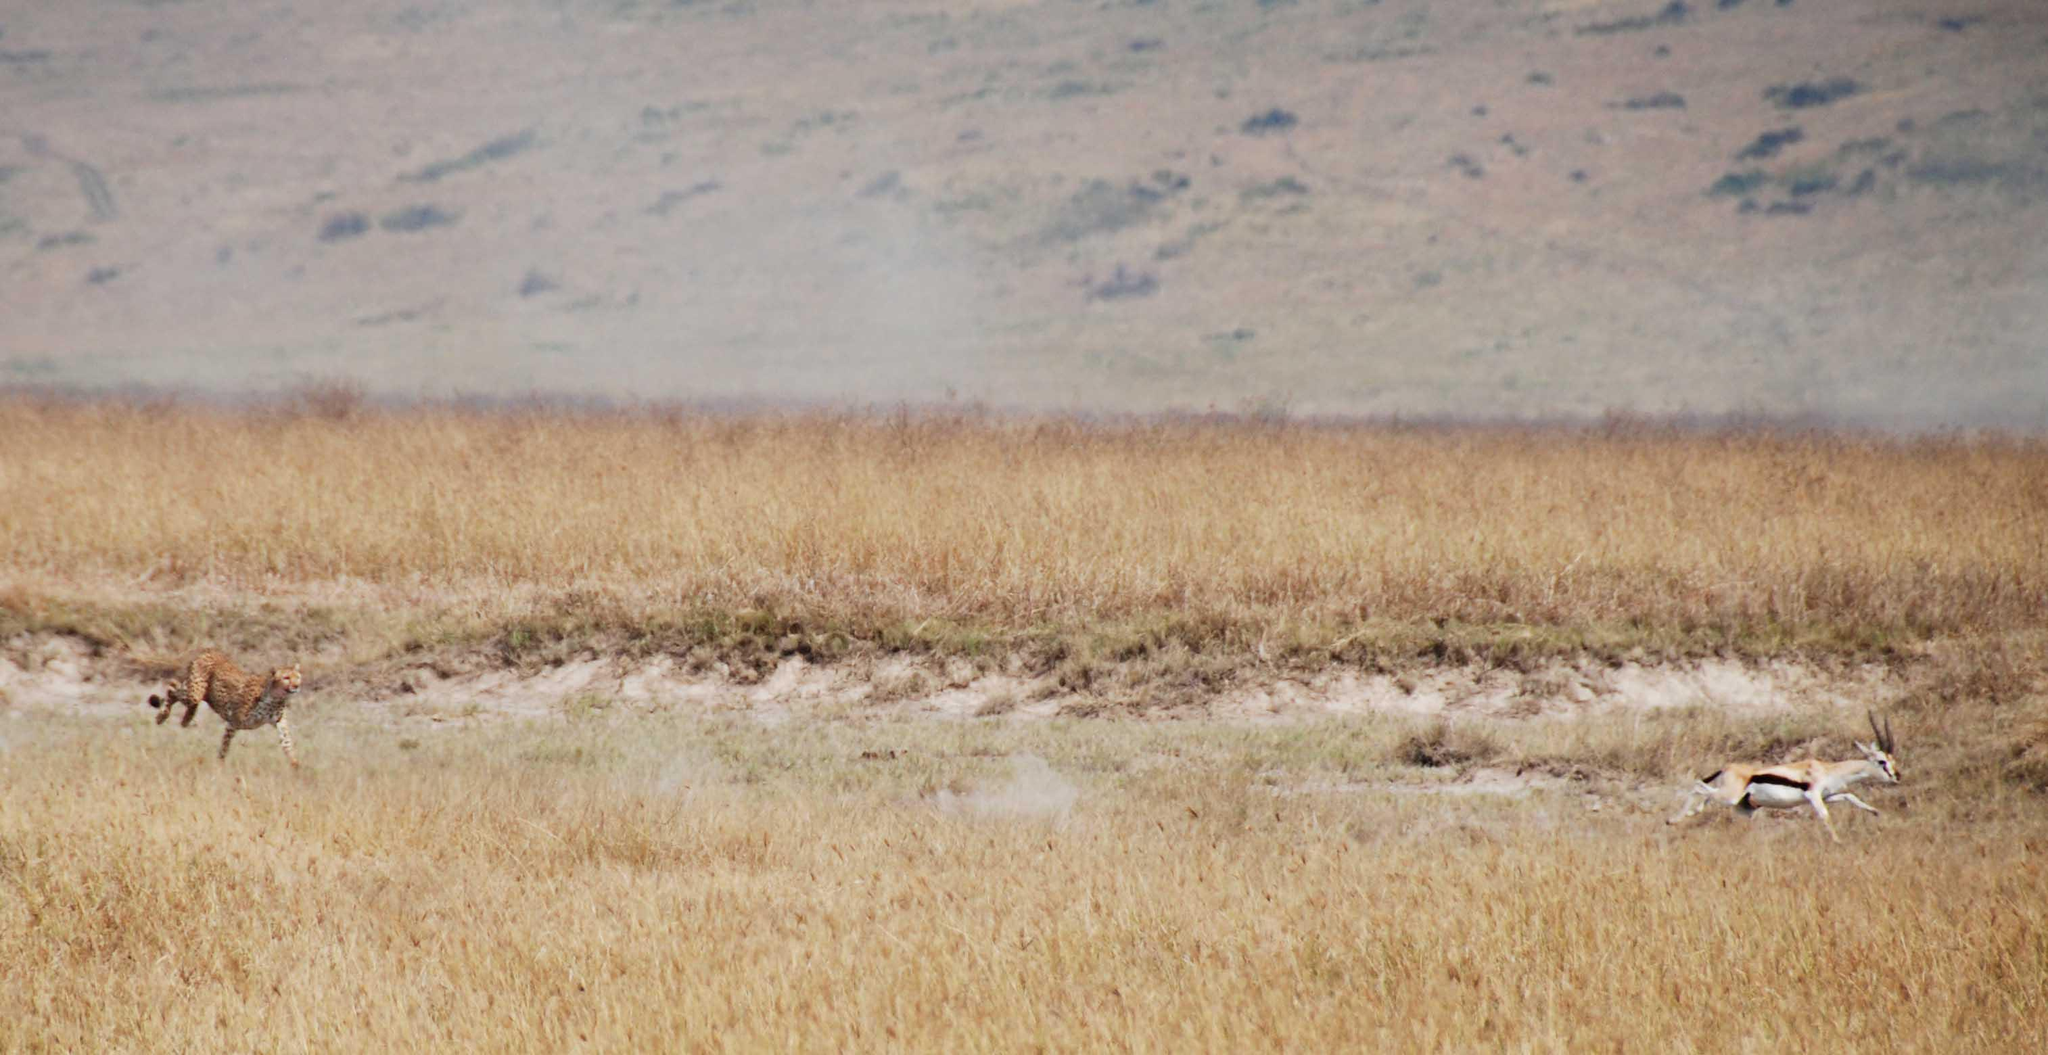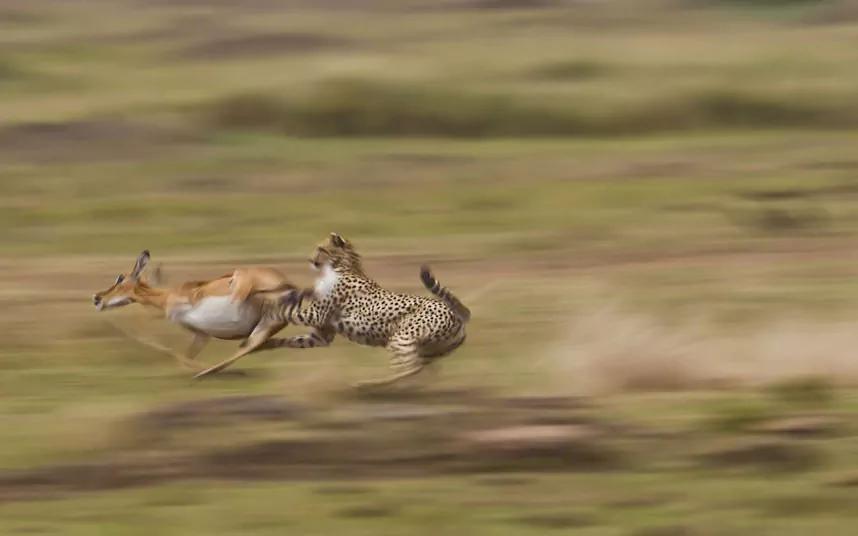The first image is the image on the left, the second image is the image on the right. Analyze the images presented: Is the assertion "In one image, a cheetah is about to capture a hooved animal as the cat strikes from behind the leftward-moving prey." valid? Answer yes or no. Yes. The first image is the image on the left, the second image is the image on the right. For the images shown, is this caption "In at least one image there is a single cheete with it's paw touch the elk it is chasing down." true? Answer yes or no. Yes. 